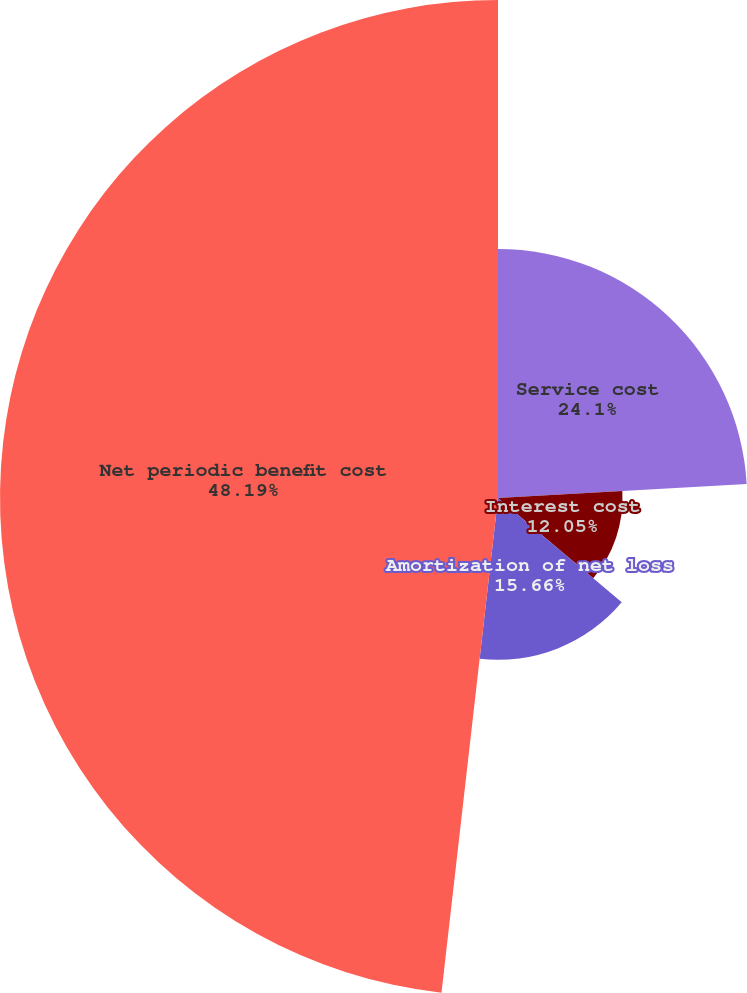Convert chart. <chart><loc_0><loc_0><loc_500><loc_500><pie_chart><fcel>Service cost<fcel>Interest cost<fcel>Amortization of net loss<fcel>Net periodic benefit cost<nl><fcel>24.1%<fcel>12.05%<fcel>15.66%<fcel>48.19%<nl></chart> 